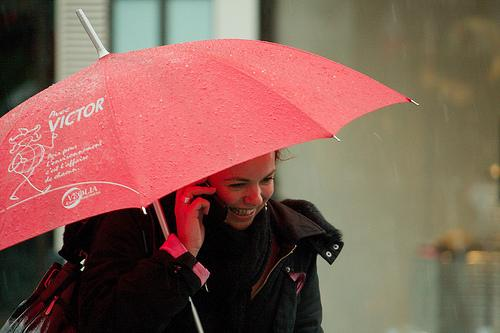Mention what the primary figure is doing in the image while stating the items they have. A woman is holding a red umbrella and using a cell phone while carrying a black purse and wearing a ring on her finger. Provide a succinct summary of the image, emphasizing the key subject and their activities. A cheerful woman with a red umbrella, black purse, and a ring on her finger is engaging with her cell phone. Narrate the actions of the main individual in the image along with the accessories they possess. A grinning woman walks in the rain with her red umbrella, chats on her phone, and carries a black bag while wearing a ring. Write a concise description of the image, placing importance on the person and the objects they carry. A woman enjoying her rainy walk uses her phone while holding a red umbrella and a black handbag, wearing a ring. Describe the image in a short sentence, focusing on the main character and mentioning their belongings. Under a red umbrella, a smiling woman uses her cell phone, carries a black bag, and wears a distinct ring. Create a short sentence outlining the scene in the image, focusing on the person and the objects they have. A happy woman under a red umbrella is using her phone, wearing a ring, and holding a black handbag. Write a brief description of the image, highlighting the main focus and the individual's actions. A smiling woman walking in the rain is holding a red umbrella with advertising, using a black cell phone, and carrying a black bag. Briefly describe the main subject of the image and their interaction with objects around them. A woman is smiling as she talks on her cell phone, holds a red umbrella, and carries a black purse, sporting a ring on her hand. Compose a minimal description of the image, spotlighting the individual and their engagement with objects. A beaming woman, umbrella and purse in hand, happily talks on her phone, with a ring on her finger. Give a compact account of the image, concentrating on the central figure and their actions. A delighted woman is using a phone under the protection of a red umbrella, holding a black bag, and wearing a ring. Find the gold ring on the woman's left hand while she uses her cell phone. The ring is on the woman's right hand, and its color is silver, not gold. Can you identify the woman holding a blue umbrella in the image? The umbrella in the original information is red and not blue. Do the metal snaps on the hood appear to be made of bronze? No, it's not mentioned in the image. Notice the woman wearing a white scarf and jacket, smiling while on the cell phone. The woman actually wears a black scarf and jacket, not a white one. Does the woman have a tattoo on her right hand while she is using her phone? There is no mention of any tattoo in the original information. Are there any raindrops on the white umbrella? The umbrella is red, not white, and there are raindrops on it. Can you see the man wearing a black jacket walking with an umbrella? There is no mention of a man in the original information. The subject is a woman wearing a black jacket walking with an umbrella. Is the woman standing under a yellow umbrella, speaking to someone on her black cell phone? The umbrella is red, not yellow, and she is indeed speaking on a black cell phone. 